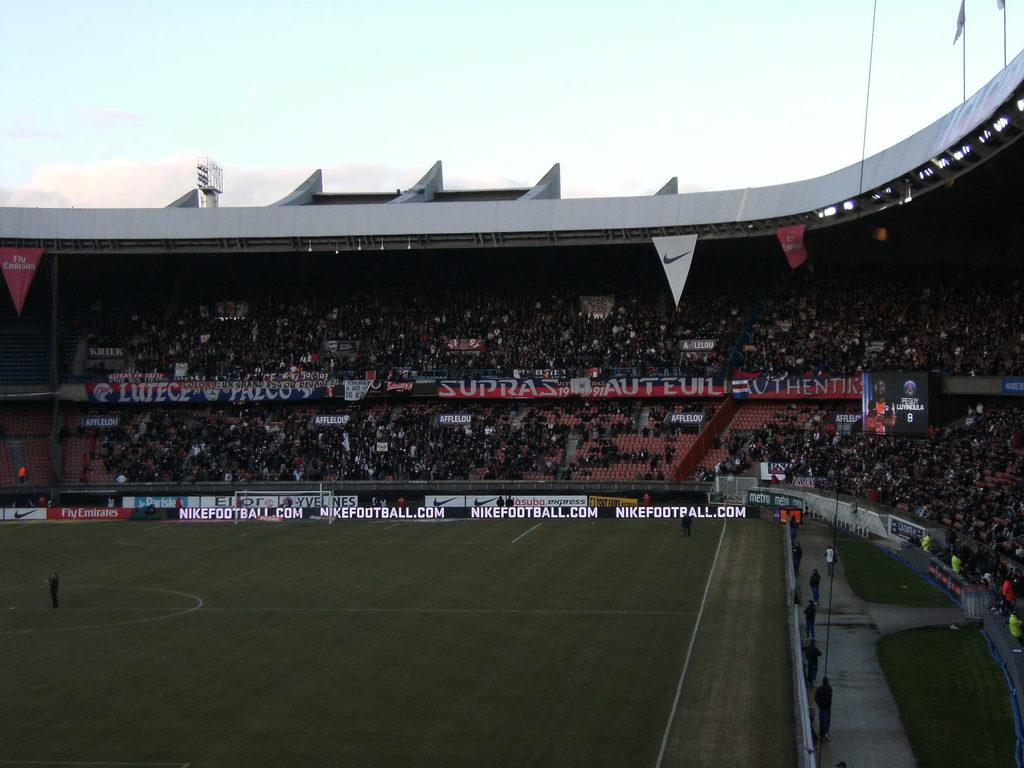What is the website shown?
Ensure brevity in your answer.  Nikefootball.com. What is the sporting event pictured?
Offer a terse response. Answering does not require reading text in the image. 